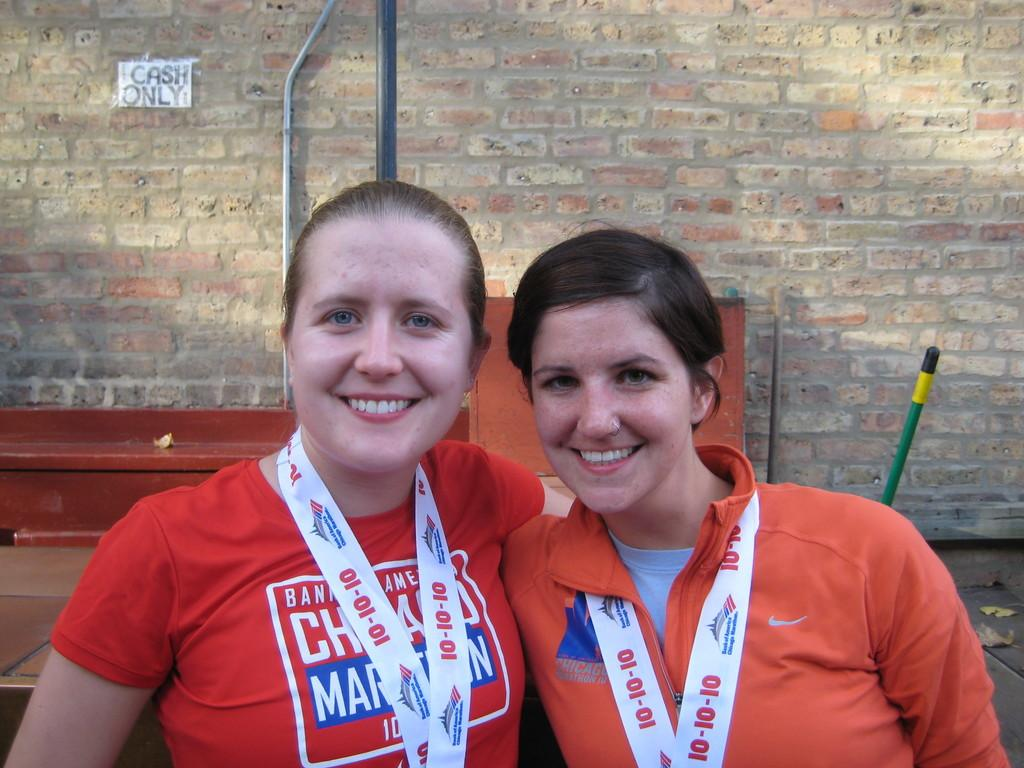Provide a one-sentence caption for the provided image. Two women posing for a photo with one wearing a chain that has the number 10 on it. 